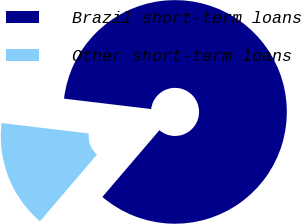Convert chart. <chart><loc_0><loc_0><loc_500><loc_500><pie_chart><fcel>Brazil short-term loans<fcel>Other short-term loans<nl><fcel>84.36%<fcel>15.64%<nl></chart> 